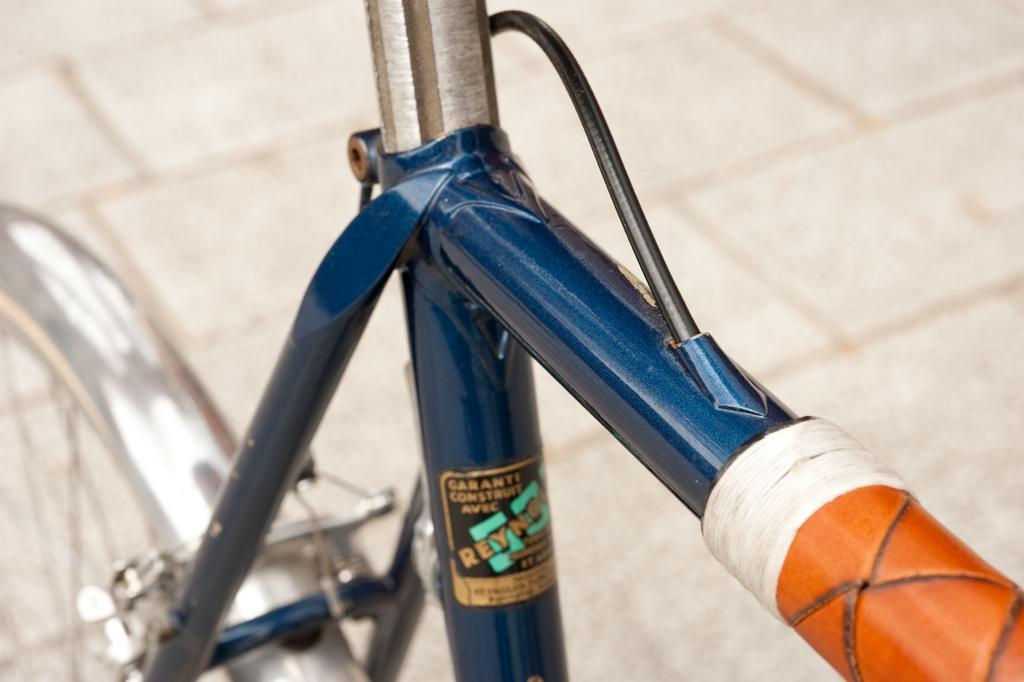Describe this image in one or two sentences. In the picture there is a partial image of a cycle,there are three rods and a wheel are visible in the picture. 